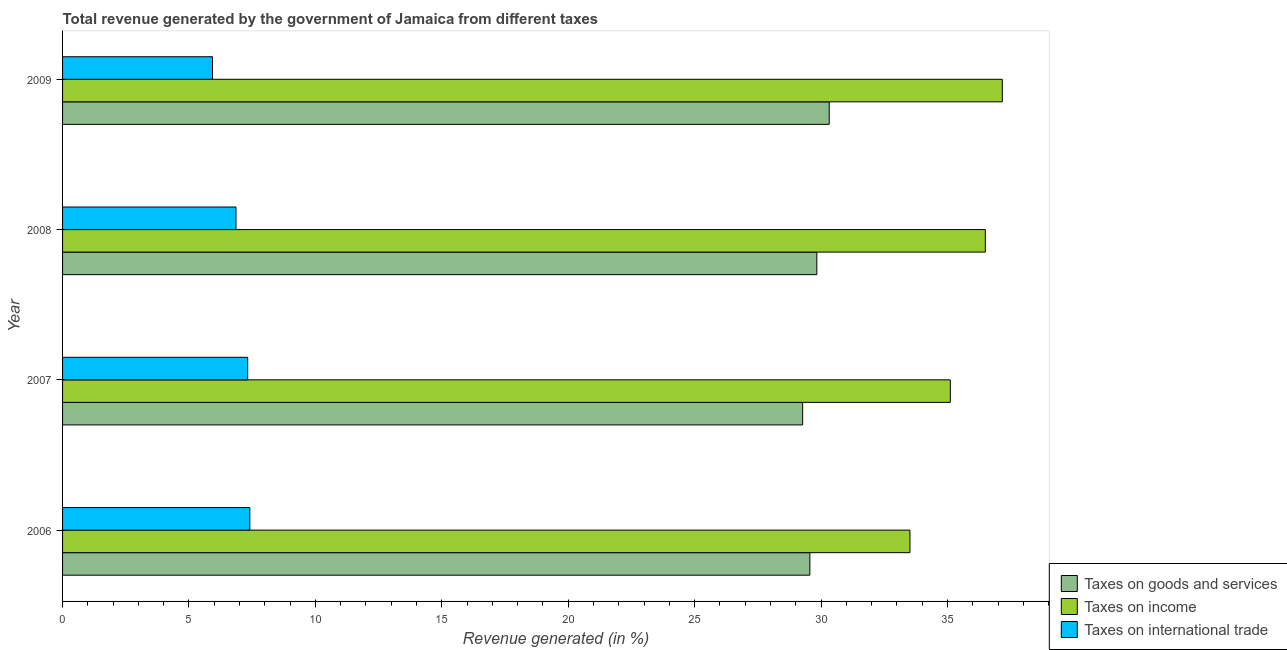Are the number of bars per tick equal to the number of legend labels?
Make the answer very short. Yes. How many bars are there on the 2nd tick from the top?
Provide a short and direct response. 3. What is the label of the 4th group of bars from the top?
Give a very brief answer. 2006. In how many cases, is the number of bars for a given year not equal to the number of legend labels?
Your response must be concise. 0. What is the percentage of revenue generated by tax on international trade in 2009?
Give a very brief answer. 5.93. Across all years, what is the maximum percentage of revenue generated by taxes on goods and services?
Keep it short and to the point. 30.32. Across all years, what is the minimum percentage of revenue generated by tax on international trade?
Offer a very short reply. 5.93. In which year was the percentage of revenue generated by tax on international trade minimum?
Ensure brevity in your answer.  2009. What is the total percentage of revenue generated by taxes on income in the graph?
Ensure brevity in your answer.  142.29. What is the difference between the percentage of revenue generated by taxes on income in 2006 and that in 2008?
Your response must be concise. -2.98. What is the difference between the percentage of revenue generated by taxes on income in 2007 and the percentage of revenue generated by taxes on goods and services in 2009?
Offer a very short reply. 4.79. What is the average percentage of revenue generated by tax on international trade per year?
Keep it short and to the point. 6.88. In the year 2008, what is the difference between the percentage of revenue generated by tax on international trade and percentage of revenue generated by taxes on income?
Your answer should be very brief. -29.64. In how many years, is the percentage of revenue generated by taxes on income greater than 2 %?
Your answer should be compact. 4. What is the ratio of the percentage of revenue generated by tax on international trade in 2006 to that in 2008?
Give a very brief answer. 1.08. What is the difference between the highest and the second highest percentage of revenue generated by tax on international trade?
Your response must be concise. 0.09. What is the difference between the highest and the lowest percentage of revenue generated by taxes on income?
Offer a terse response. 3.65. What does the 3rd bar from the top in 2008 represents?
Offer a terse response. Taxes on goods and services. What does the 2nd bar from the bottom in 2006 represents?
Your answer should be compact. Taxes on income. Is it the case that in every year, the sum of the percentage of revenue generated by taxes on goods and services and percentage of revenue generated by taxes on income is greater than the percentage of revenue generated by tax on international trade?
Your answer should be compact. Yes. How many years are there in the graph?
Your answer should be compact. 4. Does the graph contain grids?
Keep it short and to the point. No. Where does the legend appear in the graph?
Provide a succinct answer. Bottom right. How many legend labels are there?
Keep it short and to the point. 3. What is the title of the graph?
Offer a terse response. Total revenue generated by the government of Jamaica from different taxes. What is the label or title of the X-axis?
Offer a very short reply. Revenue generated (in %). What is the label or title of the Y-axis?
Offer a very short reply. Year. What is the Revenue generated (in %) of Taxes on goods and services in 2006?
Provide a short and direct response. 29.56. What is the Revenue generated (in %) of Taxes on income in 2006?
Provide a short and direct response. 33.52. What is the Revenue generated (in %) of Taxes on international trade in 2006?
Ensure brevity in your answer.  7.41. What is the Revenue generated (in %) in Taxes on goods and services in 2007?
Your response must be concise. 29.27. What is the Revenue generated (in %) in Taxes on income in 2007?
Keep it short and to the point. 35.11. What is the Revenue generated (in %) in Taxes on international trade in 2007?
Your answer should be very brief. 7.32. What is the Revenue generated (in %) in Taxes on goods and services in 2008?
Keep it short and to the point. 29.83. What is the Revenue generated (in %) of Taxes on income in 2008?
Provide a succinct answer. 36.5. What is the Revenue generated (in %) in Taxes on international trade in 2008?
Give a very brief answer. 6.86. What is the Revenue generated (in %) of Taxes on goods and services in 2009?
Give a very brief answer. 30.32. What is the Revenue generated (in %) of Taxes on income in 2009?
Ensure brevity in your answer.  37.17. What is the Revenue generated (in %) in Taxes on international trade in 2009?
Keep it short and to the point. 5.93. Across all years, what is the maximum Revenue generated (in %) of Taxes on goods and services?
Your response must be concise. 30.32. Across all years, what is the maximum Revenue generated (in %) in Taxes on income?
Provide a short and direct response. 37.17. Across all years, what is the maximum Revenue generated (in %) in Taxes on international trade?
Provide a succinct answer. 7.41. Across all years, what is the minimum Revenue generated (in %) in Taxes on goods and services?
Provide a succinct answer. 29.27. Across all years, what is the minimum Revenue generated (in %) of Taxes on income?
Your response must be concise. 33.52. Across all years, what is the minimum Revenue generated (in %) in Taxes on international trade?
Offer a very short reply. 5.93. What is the total Revenue generated (in %) in Taxes on goods and services in the graph?
Offer a terse response. 118.98. What is the total Revenue generated (in %) in Taxes on income in the graph?
Provide a short and direct response. 142.29. What is the total Revenue generated (in %) in Taxes on international trade in the graph?
Ensure brevity in your answer.  27.52. What is the difference between the Revenue generated (in %) in Taxes on goods and services in 2006 and that in 2007?
Provide a short and direct response. 0.28. What is the difference between the Revenue generated (in %) of Taxes on income in 2006 and that in 2007?
Make the answer very short. -1.6. What is the difference between the Revenue generated (in %) in Taxes on international trade in 2006 and that in 2007?
Your answer should be very brief. 0.08. What is the difference between the Revenue generated (in %) in Taxes on goods and services in 2006 and that in 2008?
Ensure brevity in your answer.  -0.28. What is the difference between the Revenue generated (in %) of Taxes on income in 2006 and that in 2008?
Your answer should be compact. -2.98. What is the difference between the Revenue generated (in %) in Taxes on international trade in 2006 and that in 2008?
Ensure brevity in your answer.  0.55. What is the difference between the Revenue generated (in %) in Taxes on goods and services in 2006 and that in 2009?
Your response must be concise. -0.77. What is the difference between the Revenue generated (in %) in Taxes on income in 2006 and that in 2009?
Offer a terse response. -3.65. What is the difference between the Revenue generated (in %) in Taxes on international trade in 2006 and that in 2009?
Your answer should be very brief. 1.48. What is the difference between the Revenue generated (in %) in Taxes on goods and services in 2007 and that in 2008?
Provide a succinct answer. -0.56. What is the difference between the Revenue generated (in %) in Taxes on income in 2007 and that in 2008?
Offer a terse response. -1.38. What is the difference between the Revenue generated (in %) of Taxes on international trade in 2007 and that in 2008?
Provide a short and direct response. 0.46. What is the difference between the Revenue generated (in %) in Taxes on goods and services in 2007 and that in 2009?
Give a very brief answer. -1.05. What is the difference between the Revenue generated (in %) of Taxes on income in 2007 and that in 2009?
Your answer should be compact. -2.06. What is the difference between the Revenue generated (in %) in Taxes on international trade in 2007 and that in 2009?
Keep it short and to the point. 1.39. What is the difference between the Revenue generated (in %) in Taxes on goods and services in 2008 and that in 2009?
Make the answer very short. -0.49. What is the difference between the Revenue generated (in %) in Taxes on income in 2008 and that in 2009?
Make the answer very short. -0.67. What is the difference between the Revenue generated (in %) of Taxes on international trade in 2008 and that in 2009?
Give a very brief answer. 0.93. What is the difference between the Revenue generated (in %) of Taxes on goods and services in 2006 and the Revenue generated (in %) of Taxes on income in 2007?
Your answer should be compact. -5.56. What is the difference between the Revenue generated (in %) of Taxes on goods and services in 2006 and the Revenue generated (in %) of Taxes on international trade in 2007?
Provide a succinct answer. 22.23. What is the difference between the Revenue generated (in %) of Taxes on income in 2006 and the Revenue generated (in %) of Taxes on international trade in 2007?
Make the answer very short. 26.19. What is the difference between the Revenue generated (in %) in Taxes on goods and services in 2006 and the Revenue generated (in %) in Taxes on income in 2008?
Offer a terse response. -6.94. What is the difference between the Revenue generated (in %) in Taxes on goods and services in 2006 and the Revenue generated (in %) in Taxes on international trade in 2008?
Provide a succinct answer. 22.7. What is the difference between the Revenue generated (in %) of Taxes on income in 2006 and the Revenue generated (in %) of Taxes on international trade in 2008?
Give a very brief answer. 26.66. What is the difference between the Revenue generated (in %) in Taxes on goods and services in 2006 and the Revenue generated (in %) in Taxes on income in 2009?
Offer a very short reply. -7.61. What is the difference between the Revenue generated (in %) in Taxes on goods and services in 2006 and the Revenue generated (in %) in Taxes on international trade in 2009?
Ensure brevity in your answer.  23.63. What is the difference between the Revenue generated (in %) in Taxes on income in 2006 and the Revenue generated (in %) in Taxes on international trade in 2009?
Your response must be concise. 27.58. What is the difference between the Revenue generated (in %) of Taxes on goods and services in 2007 and the Revenue generated (in %) of Taxes on income in 2008?
Offer a very short reply. -7.22. What is the difference between the Revenue generated (in %) in Taxes on goods and services in 2007 and the Revenue generated (in %) in Taxes on international trade in 2008?
Give a very brief answer. 22.41. What is the difference between the Revenue generated (in %) in Taxes on income in 2007 and the Revenue generated (in %) in Taxes on international trade in 2008?
Keep it short and to the point. 28.25. What is the difference between the Revenue generated (in %) in Taxes on goods and services in 2007 and the Revenue generated (in %) in Taxes on income in 2009?
Keep it short and to the point. -7.9. What is the difference between the Revenue generated (in %) in Taxes on goods and services in 2007 and the Revenue generated (in %) in Taxes on international trade in 2009?
Offer a terse response. 23.34. What is the difference between the Revenue generated (in %) in Taxes on income in 2007 and the Revenue generated (in %) in Taxes on international trade in 2009?
Make the answer very short. 29.18. What is the difference between the Revenue generated (in %) of Taxes on goods and services in 2008 and the Revenue generated (in %) of Taxes on income in 2009?
Your response must be concise. -7.34. What is the difference between the Revenue generated (in %) of Taxes on goods and services in 2008 and the Revenue generated (in %) of Taxes on international trade in 2009?
Provide a succinct answer. 23.9. What is the difference between the Revenue generated (in %) in Taxes on income in 2008 and the Revenue generated (in %) in Taxes on international trade in 2009?
Make the answer very short. 30.57. What is the average Revenue generated (in %) of Taxes on goods and services per year?
Provide a succinct answer. 29.75. What is the average Revenue generated (in %) in Taxes on income per year?
Your response must be concise. 35.57. What is the average Revenue generated (in %) of Taxes on international trade per year?
Provide a succinct answer. 6.88. In the year 2006, what is the difference between the Revenue generated (in %) of Taxes on goods and services and Revenue generated (in %) of Taxes on income?
Keep it short and to the point. -3.96. In the year 2006, what is the difference between the Revenue generated (in %) of Taxes on goods and services and Revenue generated (in %) of Taxes on international trade?
Your answer should be very brief. 22.15. In the year 2006, what is the difference between the Revenue generated (in %) in Taxes on income and Revenue generated (in %) in Taxes on international trade?
Keep it short and to the point. 26.11. In the year 2007, what is the difference between the Revenue generated (in %) in Taxes on goods and services and Revenue generated (in %) in Taxes on income?
Your response must be concise. -5.84. In the year 2007, what is the difference between the Revenue generated (in %) in Taxes on goods and services and Revenue generated (in %) in Taxes on international trade?
Offer a very short reply. 21.95. In the year 2007, what is the difference between the Revenue generated (in %) in Taxes on income and Revenue generated (in %) in Taxes on international trade?
Your response must be concise. 27.79. In the year 2008, what is the difference between the Revenue generated (in %) in Taxes on goods and services and Revenue generated (in %) in Taxes on income?
Give a very brief answer. -6.66. In the year 2008, what is the difference between the Revenue generated (in %) of Taxes on goods and services and Revenue generated (in %) of Taxes on international trade?
Provide a short and direct response. 22.97. In the year 2008, what is the difference between the Revenue generated (in %) of Taxes on income and Revenue generated (in %) of Taxes on international trade?
Provide a succinct answer. 29.64. In the year 2009, what is the difference between the Revenue generated (in %) in Taxes on goods and services and Revenue generated (in %) in Taxes on income?
Ensure brevity in your answer.  -6.85. In the year 2009, what is the difference between the Revenue generated (in %) of Taxes on goods and services and Revenue generated (in %) of Taxes on international trade?
Give a very brief answer. 24.39. In the year 2009, what is the difference between the Revenue generated (in %) of Taxes on income and Revenue generated (in %) of Taxes on international trade?
Offer a very short reply. 31.24. What is the ratio of the Revenue generated (in %) of Taxes on goods and services in 2006 to that in 2007?
Your response must be concise. 1.01. What is the ratio of the Revenue generated (in %) in Taxes on income in 2006 to that in 2007?
Make the answer very short. 0.95. What is the ratio of the Revenue generated (in %) of Taxes on international trade in 2006 to that in 2007?
Give a very brief answer. 1.01. What is the ratio of the Revenue generated (in %) in Taxes on income in 2006 to that in 2008?
Provide a succinct answer. 0.92. What is the ratio of the Revenue generated (in %) of Taxes on goods and services in 2006 to that in 2009?
Offer a very short reply. 0.97. What is the ratio of the Revenue generated (in %) in Taxes on income in 2006 to that in 2009?
Keep it short and to the point. 0.9. What is the ratio of the Revenue generated (in %) of Taxes on international trade in 2006 to that in 2009?
Make the answer very short. 1.25. What is the ratio of the Revenue generated (in %) in Taxes on goods and services in 2007 to that in 2008?
Provide a succinct answer. 0.98. What is the ratio of the Revenue generated (in %) of Taxes on income in 2007 to that in 2008?
Offer a terse response. 0.96. What is the ratio of the Revenue generated (in %) in Taxes on international trade in 2007 to that in 2008?
Your answer should be compact. 1.07. What is the ratio of the Revenue generated (in %) in Taxes on goods and services in 2007 to that in 2009?
Make the answer very short. 0.97. What is the ratio of the Revenue generated (in %) in Taxes on income in 2007 to that in 2009?
Offer a very short reply. 0.94. What is the ratio of the Revenue generated (in %) in Taxes on international trade in 2007 to that in 2009?
Give a very brief answer. 1.23. What is the ratio of the Revenue generated (in %) of Taxes on goods and services in 2008 to that in 2009?
Give a very brief answer. 0.98. What is the ratio of the Revenue generated (in %) of Taxes on income in 2008 to that in 2009?
Your answer should be compact. 0.98. What is the ratio of the Revenue generated (in %) in Taxes on international trade in 2008 to that in 2009?
Your answer should be compact. 1.16. What is the difference between the highest and the second highest Revenue generated (in %) of Taxes on goods and services?
Provide a succinct answer. 0.49. What is the difference between the highest and the second highest Revenue generated (in %) of Taxes on income?
Your response must be concise. 0.67. What is the difference between the highest and the second highest Revenue generated (in %) of Taxes on international trade?
Offer a terse response. 0.08. What is the difference between the highest and the lowest Revenue generated (in %) of Taxes on goods and services?
Give a very brief answer. 1.05. What is the difference between the highest and the lowest Revenue generated (in %) of Taxes on income?
Make the answer very short. 3.65. What is the difference between the highest and the lowest Revenue generated (in %) in Taxes on international trade?
Keep it short and to the point. 1.48. 